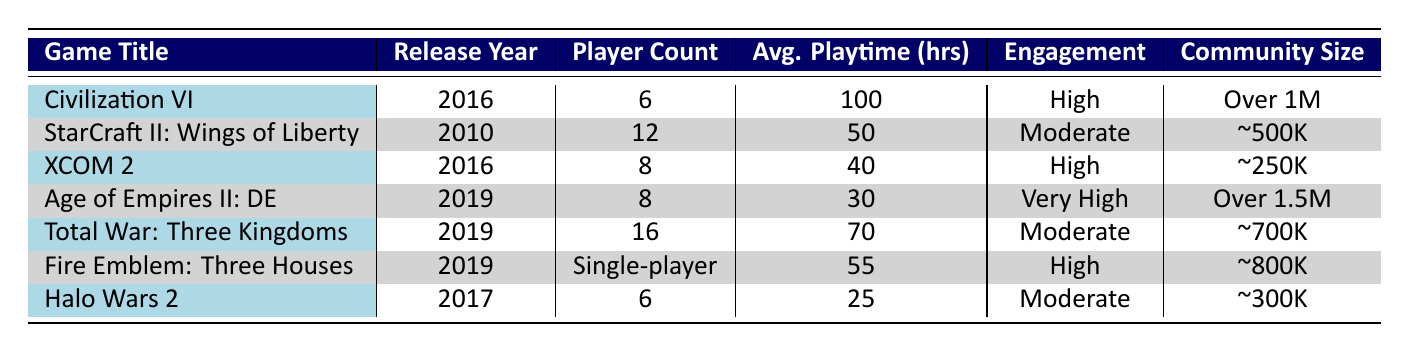What is the release year of "Civilization VI"? The table shows the release year for "Civilization VI" is listed next to the game title, which indicates that it was released in 2016.
Answer: 2016 Which game has the highest average playtime? The average playtime hours are given for each game. "Civilization VI" has the highest average playtime of 100 hours compared to all other games in the table.
Answer: Civilization VI How many active players are there in "Age of Empires II: Definitive Edition"? The table states that the community size for "Age of Empires II: Definitive Edition" is "Over 1.5 million active players."
Answer: Over 1.5 million Is "Fire Emblem: Three Houses" a multiplayer game? The "Player Count" for "Fire Emblem: Three Houses" is listed as "Single-player," indicating that it is not multiplayer.
Answer: No What are the engagement metrics for games released in 2019? The games released in 2019 include "Age of Empires II: Definitive Edition," "Total War: Three Kingdoms," and "Fire Emblem: Three Houses," which have engagement metrics listed as "Very High," "Moderate," and "High," respectively.
Answer: Very High, Moderate, High How many total hours do players typically average in "StarCraft II: Wings of Liberty" and "Halo Wars 2"? The average playtime for "StarCraft II: Wings of Liberty" is 50 hours, and for "Halo Wars 2," it is 25 hours. Summing these gives 50 + 25 = 75 hours.
Answer: 75 hours Which game has the smallest community size, and what is that size? The game with the smallest community size is "XCOM 2," with about 250,000 active players, as noted in the table.
Answer: About 250,000 active players Are there any games with a "Moderate" engagement metric that are single-player? The table indicates that "Fire Emblem: Three Houses" is single-player, but its engagement metric is "High," not "Moderate." "Total War: Three Kingdoms" has a "Moderate" engagement metric and is multiplayer. Hence, no single-player games fit this criterion.
Answer: No What is the difference in average playtime between "Civilization VI" and "XCOM 2"? The average playtime for "Civilization VI" is 100 hours, while for "XCOM 2," it is 40 hours. The difference is 100 - 40 = 60 hours.
Answer: 60 hours Count the number of games with "High" engagement metrics. There are three games with "High" engagement metrics: "Civilization VI," "XCOM 2," and "Fire Emblem: Three Houses," as per the table.
Answer: 3 